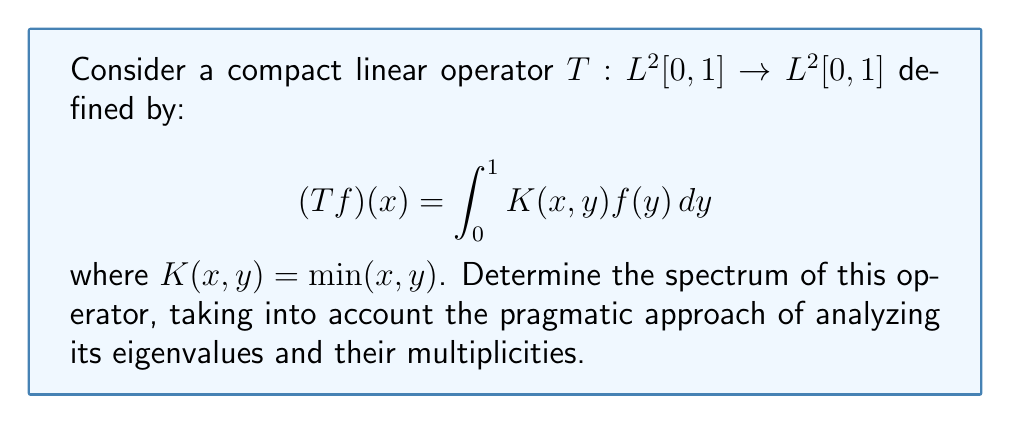Give your solution to this math problem. 1) First, we need to find the eigenvalues and eigenfunctions of T. Let λ be an eigenvalue and f be the corresponding eigenfunction. Then:

   $$λf(x) = \int_0^1 \min(x,y)f(y)dy$$

2) Differentiating both sides with respect to x:

   $$λf'(x) = \int_x^1 f(y)dy$$

3) Differentiating again:

   $$λf''(x) = -f(x)$$

4) This is a second-order differential equation. The general solution is:

   $$f(x) = A\sin(\frac{x}{\sqrt{λ}}) + B\cos(\frac{x}{\sqrt{λ}})$$

5) Applying the boundary conditions f(0) = 0 and f'(1) = 0:

   $$f(0) = 0 \implies B = 0$$
   $$f'(1) = 0 \implies \cos(\frac{1}{\sqrt{λ}}) = 0$$

6) The second condition gives us:

   $$\frac{1}{\sqrt{λ}} = \frac{\pi}{2} + n\pi, \quad n = 0, 1, 2, ...$$

7) Therefore, the eigenvalues are:

   $$λ_n = \frac{4}{π^2(2n+1)^2}, \quad n = 0, 1, 2, ...$$

8) The corresponding eigenfunctions are:

   $$f_n(x) = \sin(\frac{\pi}{2}(2n+1)x), \quad n = 0, 1, 2, ...$$

9) Since T is compact and self-adjoint, its spectrum consists of these eigenvalues and possibly 0.

10) The eigenvalues converge to 0 as n approaches infinity, confirming that 0 is indeed in the spectrum.

Therefore, the spectrum of T is the set of all eigenvalues and 0.
Answer: $\{0\} \cup \{\frac{4}{π^2(2n+1)^2} : n = 0, 1, 2, ...\}$ 